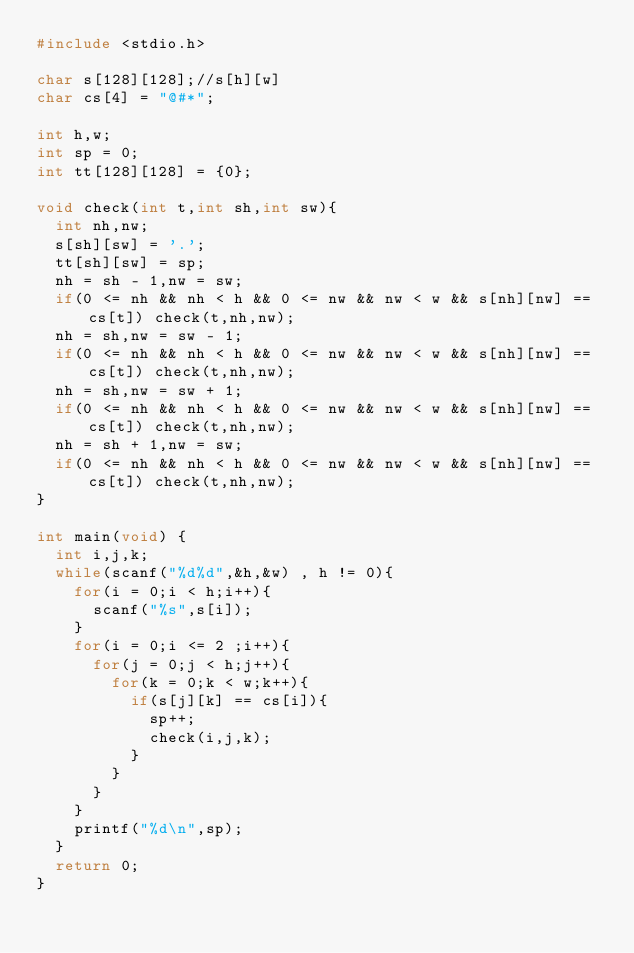Convert code to text. <code><loc_0><loc_0><loc_500><loc_500><_C_>#include <stdio.h>

char s[128][128];//s[h][w]
char cs[4] = "@#*";

int h,w;
int sp = 0;
int tt[128][128] = {0};

void check(int t,int sh,int sw){
	int nh,nw;
	s[sh][sw] = '.';
	tt[sh][sw] = sp;
	nh = sh - 1,nw = sw;
	if(0 <= nh && nh < h && 0 <= nw && nw < w && s[nh][nw] == cs[t]) check(t,nh,nw);
	nh = sh,nw = sw - 1;
	if(0 <= nh && nh < h && 0 <= nw && nw < w && s[nh][nw] == cs[t]) check(t,nh,nw);
	nh = sh,nw = sw + 1;
	if(0 <= nh && nh < h && 0 <= nw && nw < w && s[nh][nw] == cs[t]) check(t,nh,nw);
	nh = sh + 1,nw = sw;
	if(0 <= nh && nh < h && 0 <= nw && nw < w && s[nh][nw] == cs[t]) check(t,nh,nw);
}

int main(void) {
	int i,j,k;
	while(scanf("%d%d",&h,&w) , h != 0){
		for(i = 0;i < h;i++){
			scanf("%s",s[i]);
		}
		for(i = 0;i <= 2 ;i++){
			for(j = 0;j < h;j++){
				for(k = 0;k < w;k++){
					if(s[j][k] == cs[i]){
						sp++;
						check(i,j,k);
					}
				}
			}
		}
		printf("%d\n",sp);
	}
	return 0;
}</code> 